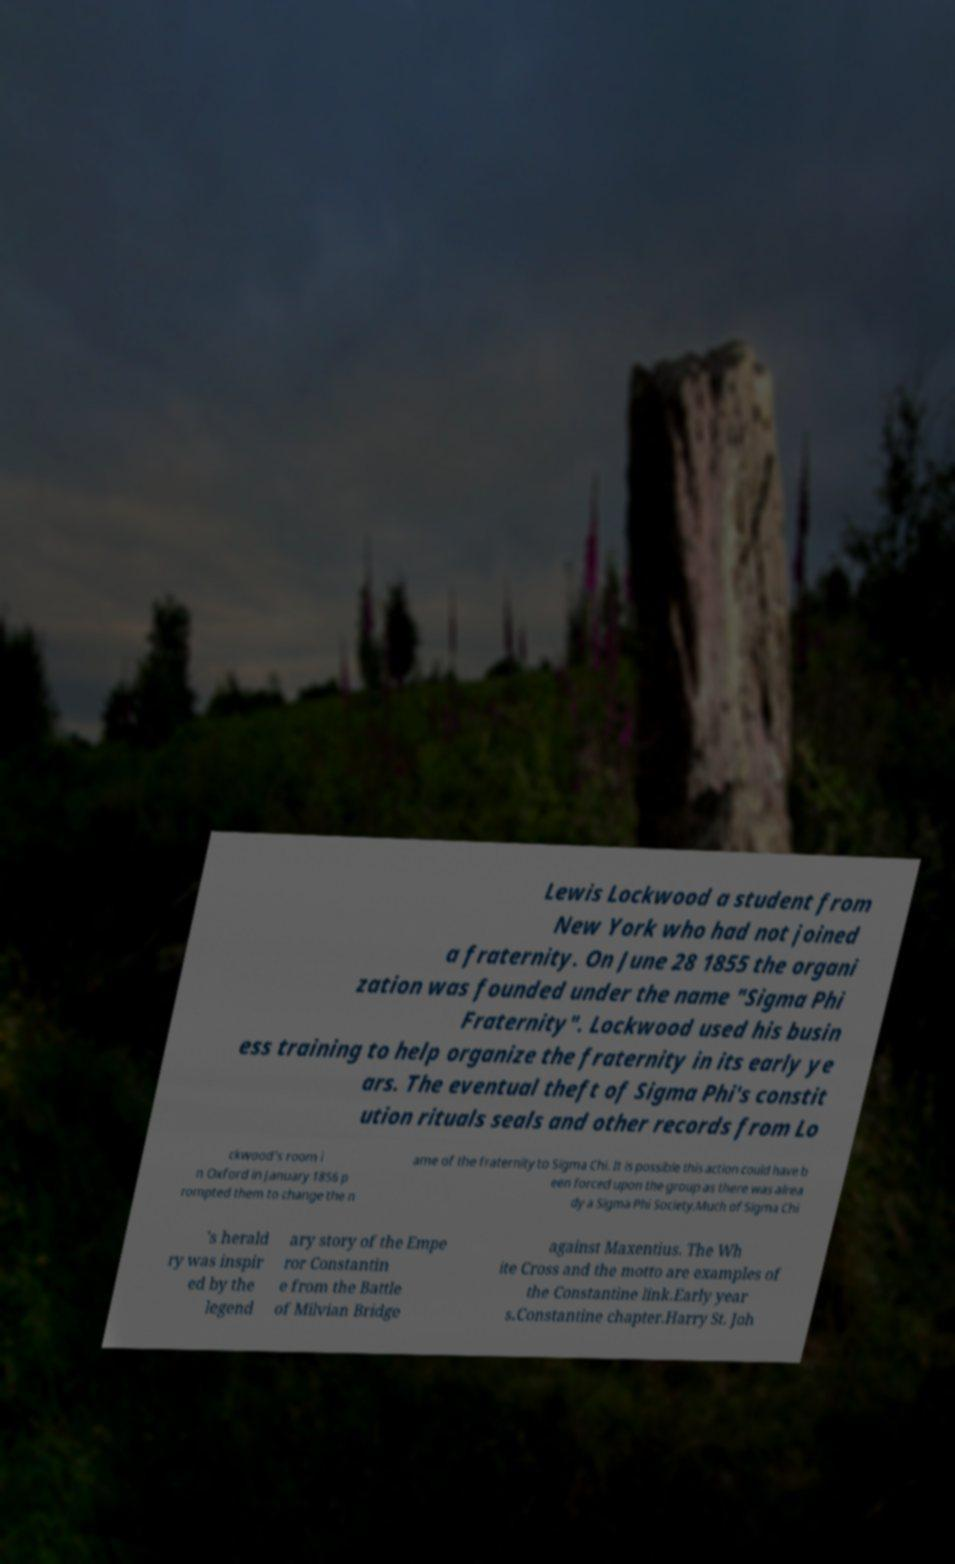What messages or text are displayed in this image? I need them in a readable, typed format. Lewis Lockwood a student from New York who had not joined a fraternity. On June 28 1855 the organi zation was founded under the name "Sigma Phi Fraternity". Lockwood used his busin ess training to help organize the fraternity in its early ye ars. The eventual theft of Sigma Phi's constit ution rituals seals and other records from Lo ckwood's room i n Oxford in January 1856 p rompted them to change the n ame of the fraternity to Sigma Chi. It is possible this action could have b een forced upon the group as there was alrea dy a Sigma Phi Society.Much of Sigma Chi 's herald ry was inspir ed by the legend ary story of the Empe ror Constantin e from the Battle of Milvian Bridge against Maxentius. The Wh ite Cross and the motto are examples of the Constantine link.Early year s.Constantine chapter.Harry St. Joh 